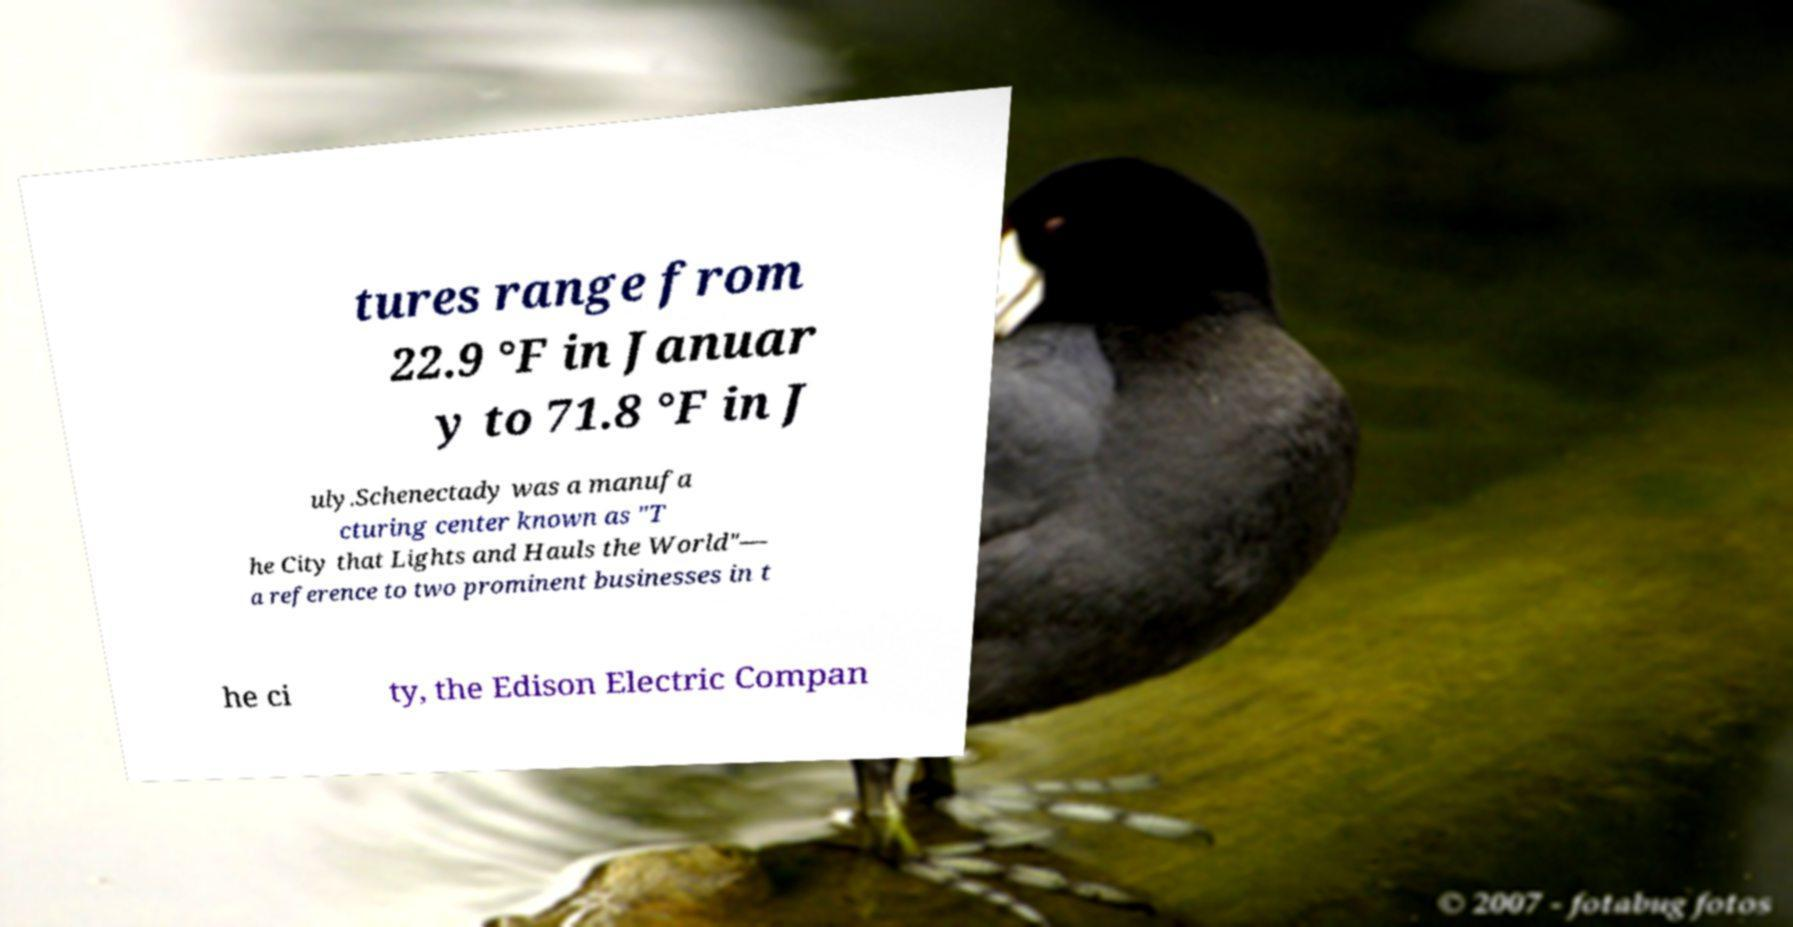Could you extract and type out the text from this image? tures range from 22.9 °F in Januar y to 71.8 °F in J uly.Schenectady was a manufa cturing center known as "T he City that Lights and Hauls the World"— a reference to two prominent businesses in t he ci ty, the Edison Electric Compan 